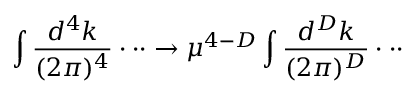<formula> <loc_0><loc_0><loc_500><loc_500>\int \frac { d ^ { 4 } k } { ( 2 \pi ) ^ { 4 } } \cdot \cdot \cdot \rightarrow \mu ^ { 4 - D } \int \frac { d ^ { D } k } { ( 2 \pi ) ^ { D } } \cdot \cdot \cdot</formula> 